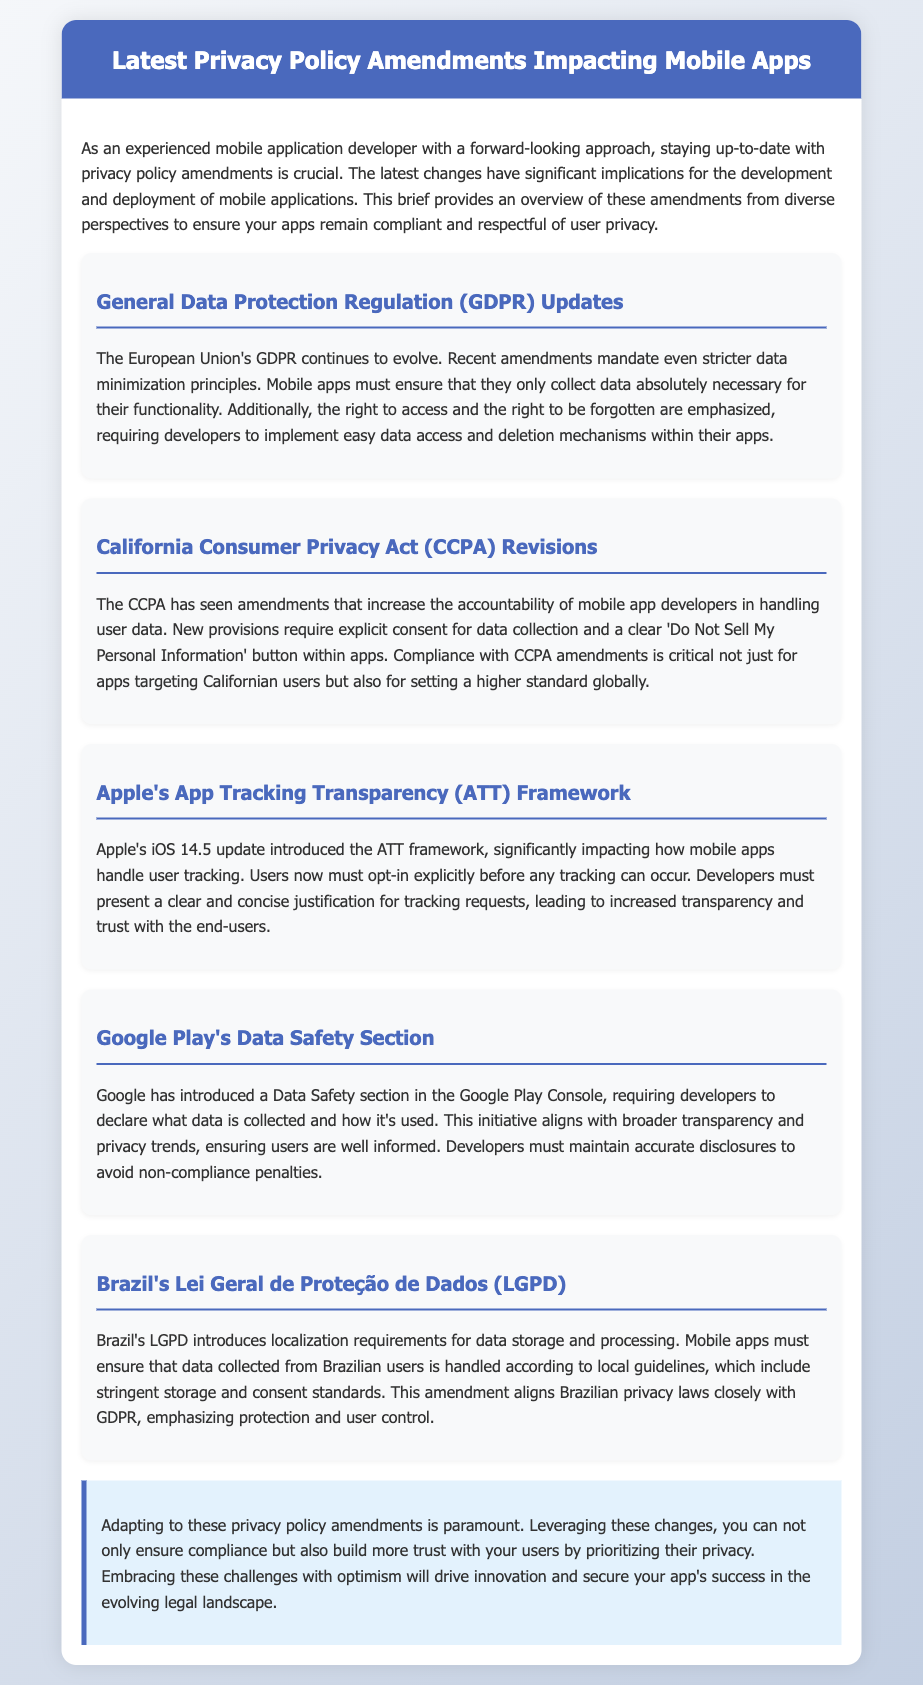What are the recent GDPR amendments focused on? The recent GDPR amendments mandate stricter data minimization principles and emphasize the right to access and the right to be forgotten.
Answer: data minimization principles What does CCPA require for data collection consent? The CCPA requires explicit consent for data collection and a clear 'Do Not Sell My Personal Information' button.
Answer: explicit consent What significant update did Apple's iOS 14.5 introduce? Apple's iOS 14.5 update introduced the App Tracking Transparency framework, requiring user opt-in for tracking.
Answer: App Tracking Transparency What does the Data Safety section in Google Play require? The Data Safety section requires developers to declare what data is collected and how it's used.
Answer: data declaration What is a notable requirement of Brazil's LGPD? Brazil's LGPD introduces localization requirements for data storage and processing.
Answer: localization requirements How should mobile apps handle data according to GDPR? Mobile apps must ensure that they only collect data absolutely necessary for their functionality.
Answer: data minimization What is the conclusion's perspective on privacy policy amendments? The conclusion emphasizes the importance of adapting to privacy policy amendments for compliance and user trust.
Answer: compliance and user trust What does the document suggest about user control in Brazil? The document notes that LGPD emphasizes protection and user control.
Answer: user control 